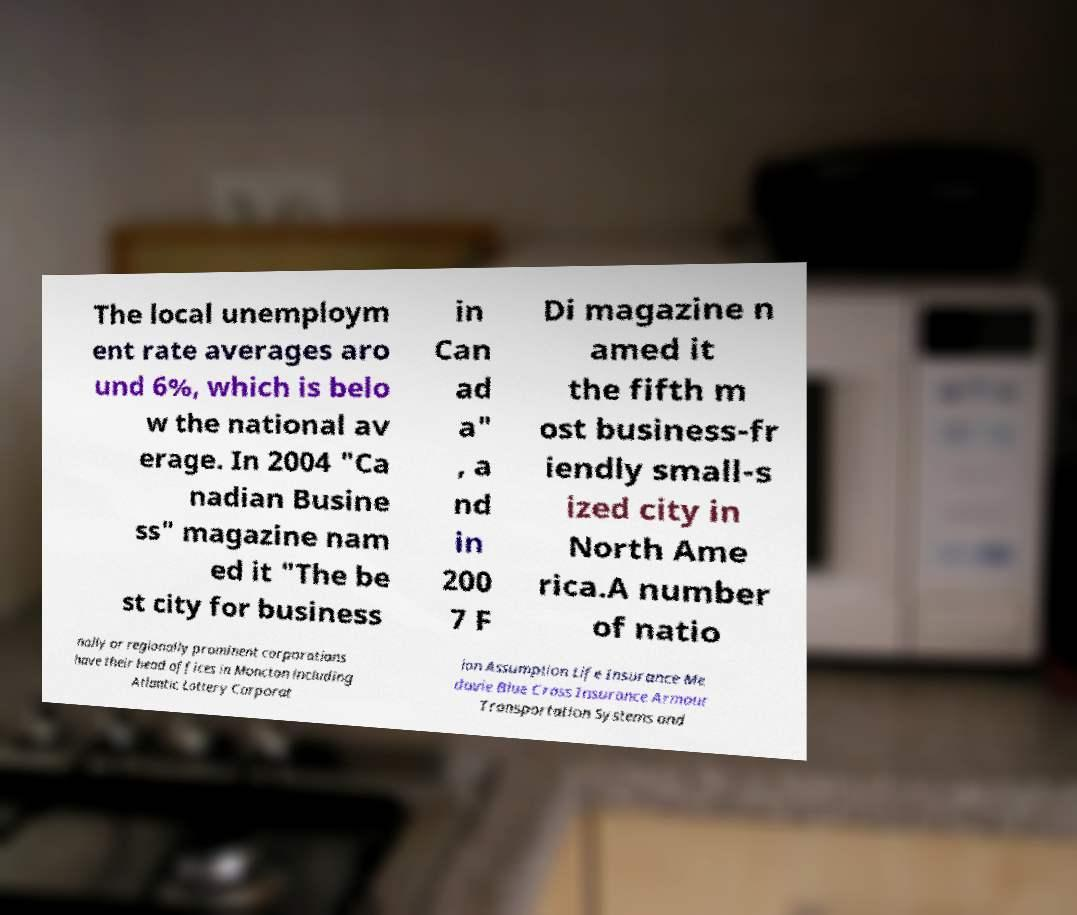Please read and relay the text visible in this image. What does it say? The local unemploym ent rate averages aro und 6%, which is belo w the national av erage. In 2004 "Ca nadian Busine ss" magazine nam ed it "The be st city for business in Can ad a" , a nd in 200 7 F Di magazine n amed it the fifth m ost business-fr iendly small-s ized city in North Ame rica.A number of natio nally or regionally prominent corporations have their head offices in Moncton including Atlantic Lottery Corporat ion Assumption Life Insurance Me davie Blue Cross Insurance Armour Transportation Systems and 